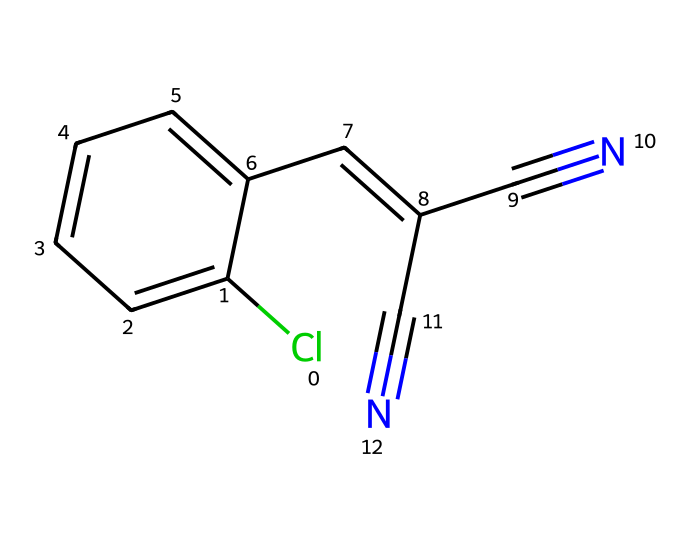What is the maximum number of carbon atoms in this compound? This SMILES representation indicates a total of 10 carbon atoms ('C') based on its structure.
Answer: 10 Which type of functional groups are present in this chemical structure? The structure contains nitrile groups indicated by 'C#N' as well as a chloro group shown by 'Cl.'
Answer: nitrile and chloro How many double bonds are in the compound? By analyzing the drawn structure, there are 3 double bonds present between carbon atoms, as depicted in the SMILES.
Answer: 3 What is the overall molecular formula for this compound? The counting of atoms from the structure results in a total formula of C10H6ClN2.
Answer: C10H6ClN2 Does this compound have any aromatic rings? The presence of alternating double bonds in a six-membered carbon ring confirms that there is an aromatic ring structure in this compound.
Answer: yes What is the primary type of bonding interactions present in this compound? The compound features covalent bonding primarily between carbon, nitrogen, chlorine, showcasing strong molecular interactions.
Answer: covalent bonding 